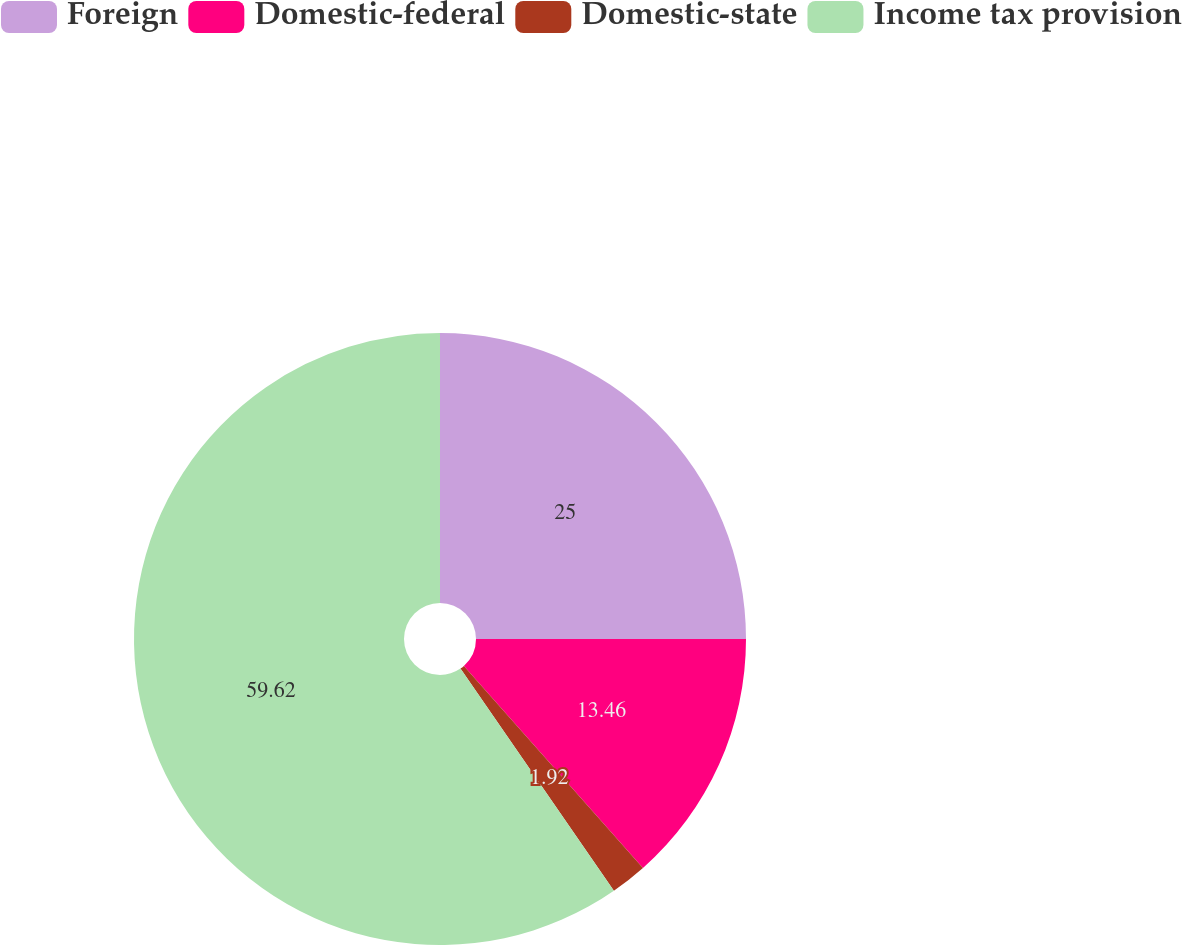Convert chart. <chart><loc_0><loc_0><loc_500><loc_500><pie_chart><fcel>Foreign<fcel>Domestic-federal<fcel>Domestic-state<fcel>Income tax provision<nl><fcel>25.0%<fcel>13.46%<fcel>1.92%<fcel>59.62%<nl></chart> 